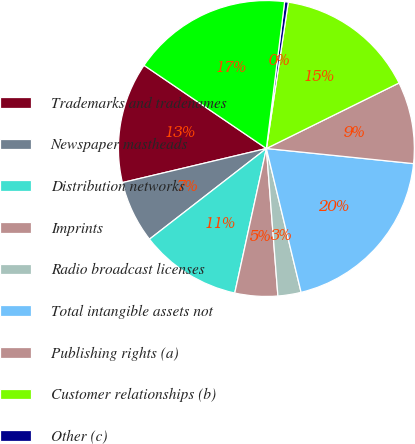Convert chart to OTSL. <chart><loc_0><loc_0><loc_500><loc_500><pie_chart><fcel>Trademarks and tradenames<fcel>Newspaper mastheads<fcel>Distribution networks<fcel>Imprints<fcel>Radio broadcast licenses<fcel>Total intangible assets not<fcel>Publishing rights (a)<fcel>Customer relationships (b)<fcel>Other (c)<fcel>Total intangible assets<nl><fcel>13.2%<fcel>6.8%<fcel>11.07%<fcel>4.67%<fcel>2.53%<fcel>19.6%<fcel>8.93%<fcel>15.33%<fcel>0.4%<fcel>17.47%<nl></chart> 